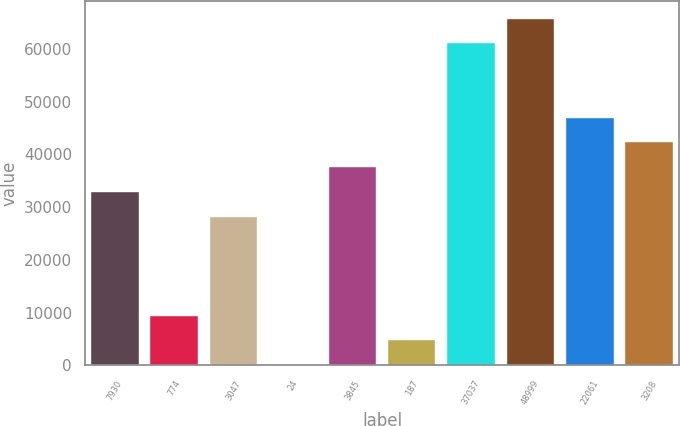Convert chart to OTSL. <chart><loc_0><loc_0><loc_500><loc_500><bar_chart><fcel>7930<fcel>774<fcel>3047<fcel>24<fcel>3845<fcel>187<fcel>37037<fcel>48999<fcel>22061<fcel>3208<nl><fcel>32877<fcel>9437<fcel>28189<fcel>61<fcel>37565<fcel>4749<fcel>61005<fcel>65693<fcel>46941<fcel>42253<nl></chart> 